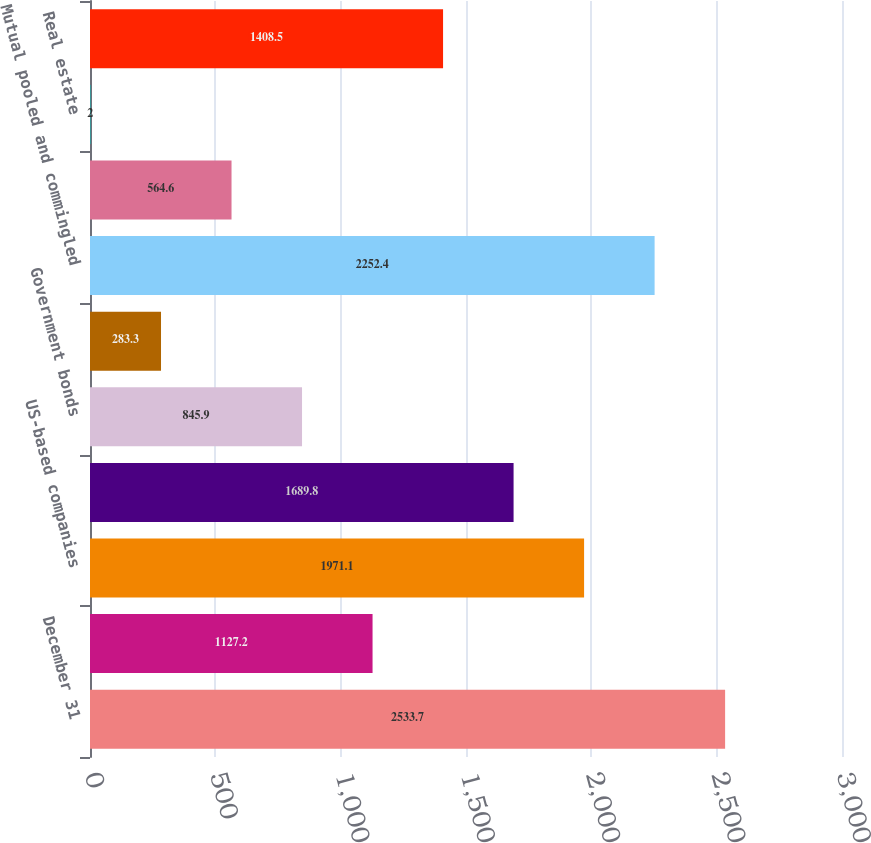<chart> <loc_0><loc_0><loc_500><loc_500><bar_chart><fcel>December 31<fcel>Cash and cash equivalents<fcel>US-based companies<fcel>International-based companies<fcel>Government bonds<fcel>Corporate bonds and debt<fcel>Mutual pooled and commingled<fcel>Hedge funds/limited<fcel>Real estate<fcel>Other<nl><fcel>2533.7<fcel>1127.2<fcel>1971.1<fcel>1689.8<fcel>845.9<fcel>283.3<fcel>2252.4<fcel>564.6<fcel>2<fcel>1408.5<nl></chart> 